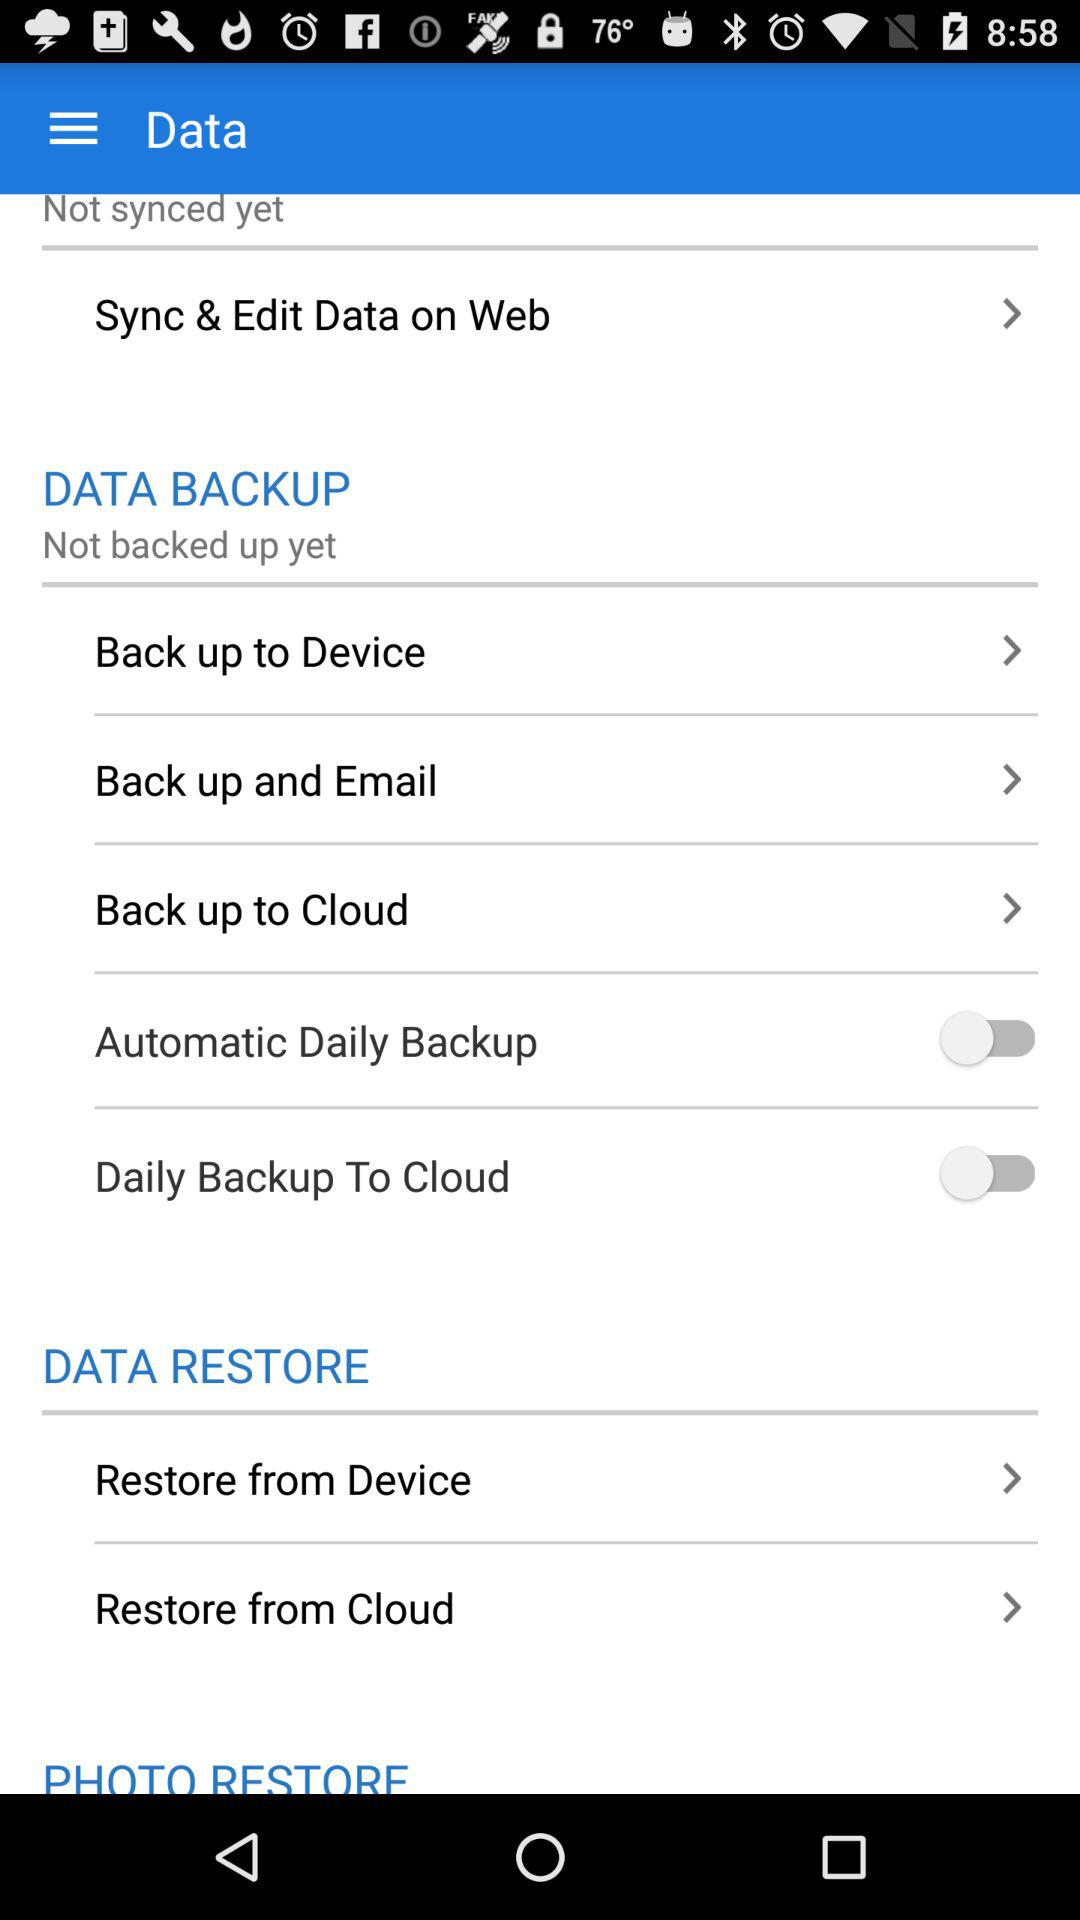What is the status of "Daily Backup To Cloud"? The status is off. 